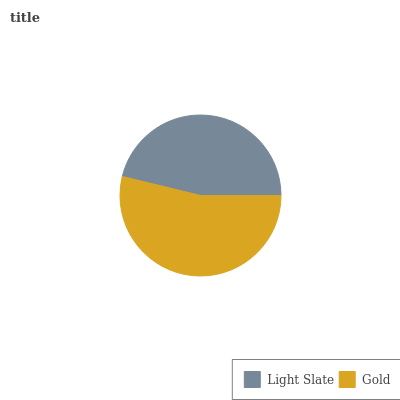Is Light Slate the minimum?
Answer yes or no. Yes. Is Gold the maximum?
Answer yes or no. Yes. Is Gold the minimum?
Answer yes or no. No. Is Gold greater than Light Slate?
Answer yes or no. Yes. Is Light Slate less than Gold?
Answer yes or no. Yes. Is Light Slate greater than Gold?
Answer yes or no. No. Is Gold less than Light Slate?
Answer yes or no. No. Is Gold the high median?
Answer yes or no. Yes. Is Light Slate the low median?
Answer yes or no. Yes. Is Light Slate the high median?
Answer yes or no. No. Is Gold the low median?
Answer yes or no. No. 